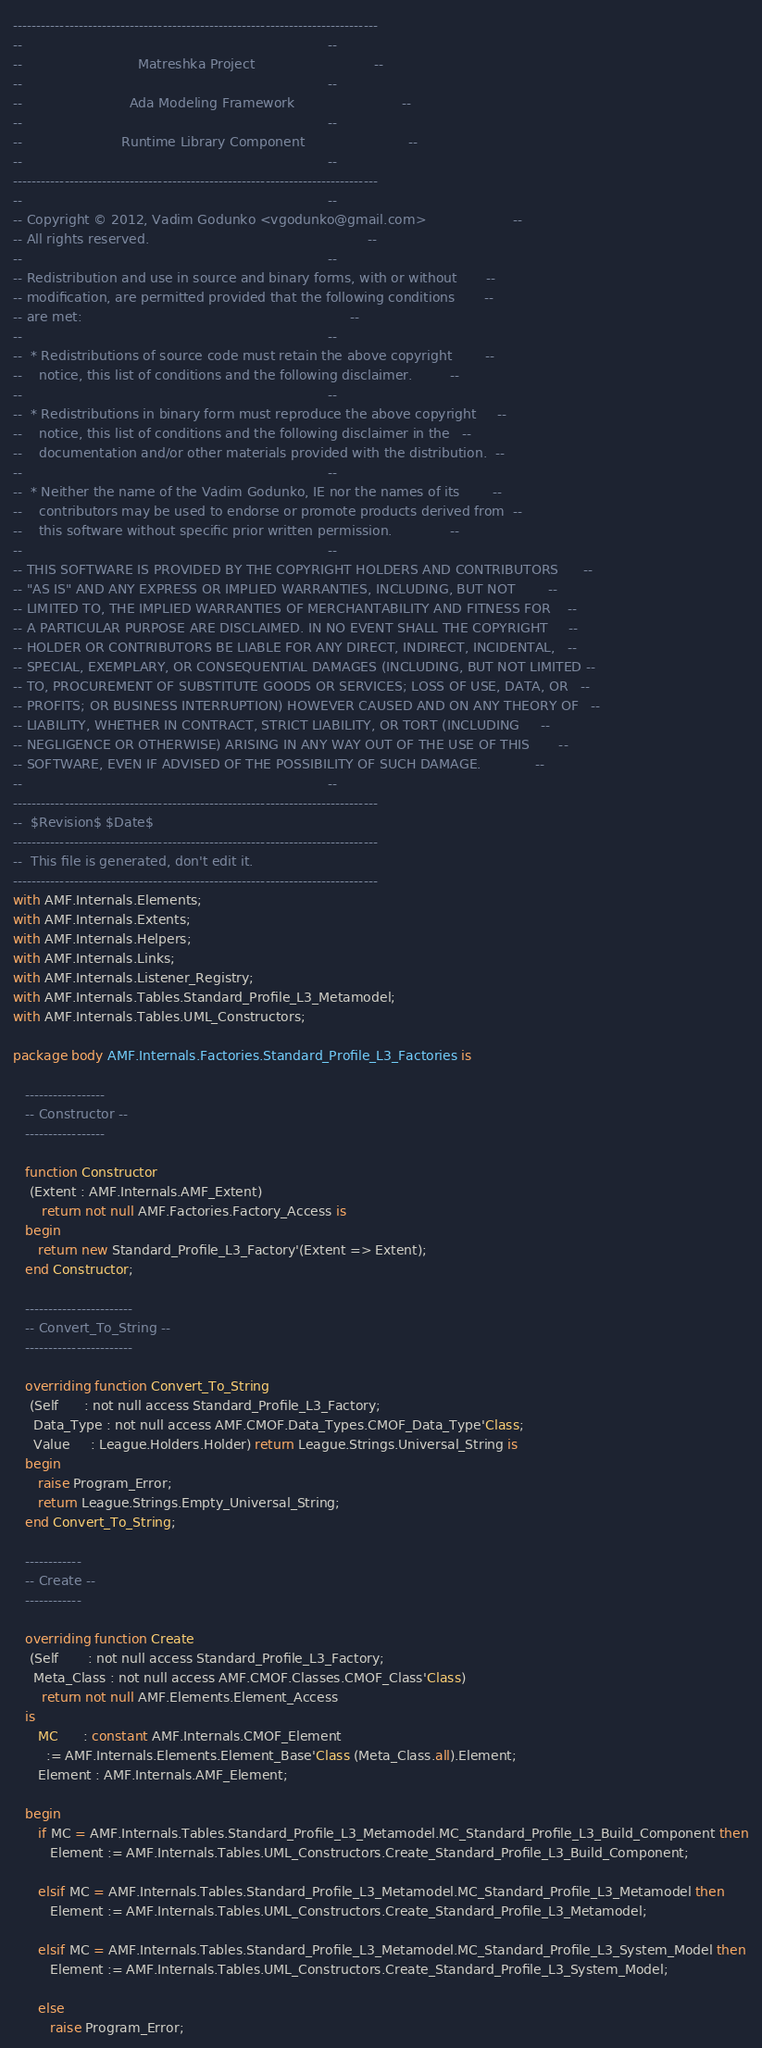<code> <loc_0><loc_0><loc_500><loc_500><_Ada_>------------------------------------------------------------------------------
--                                                                          --
--                            Matreshka Project                             --
--                                                                          --
--                          Ada Modeling Framework                          --
--                                                                          --
--                        Runtime Library Component                         --
--                                                                          --
------------------------------------------------------------------------------
--                                                                          --
-- Copyright © 2012, Vadim Godunko <vgodunko@gmail.com>                     --
-- All rights reserved.                                                     --
--                                                                          --
-- Redistribution and use in source and binary forms, with or without       --
-- modification, are permitted provided that the following conditions       --
-- are met:                                                                 --
--                                                                          --
--  * Redistributions of source code must retain the above copyright        --
--    notice, this list of conditions and the following disclaimer.         --
--                                                                          --
--  * Redistributions in binary form must reproduce the above copyright     --
--    notice, this list of conditions and the following disclaimer in the   --
--    documentation and/or other materials provided with the distribution.  --
--                                                                          --
--  * Neither the name of the Vadim Godunko, IE nor the names of its        --
--    contributors may be used to endorse or promote products derived from  --
--    this software without specific prior written permission.              --
--                                                                          --
-- THIS SOFTWARE IS PROVIDED BY THE COPYRIGHT HOLDERS AND CONTRIBUTORS      --
-- "AS IS" AND ANY EXPRESS OR IMPLIED WARRANTIES, INCLUDING, BUT NOT        --
-- LIMITED TO, THE IMPLIED WARRANTIES OF MERCHANTABILITY AND FITNESS FOR    --
-- A PARTICULAR PURPOSE ARE DISCLAIMED. IN NO EVENT SHALL THE COPYRIGHT     --
-- HOLDER OR CONTRIBUTORS BE LIABLE FOR ANY DIRECT, INDIRECT, INCIDENTAL,   --
-- SPECIAL, EXEMPLARY, OR CONSEQUENTIAL DAMAGES (INCLUDING, BUT NOT LIMITED --
-- TO, PROCUREMENT OF SUBSTITUTE GOODS OR SERVICES; LOSS OF USE, DATA, OR   --
-- PROFITS; OR BUSINESS INTERRUPTION) HOWEVER CAUSED AND ON ANY THEORY OF   --
-- LIABILITY, WHETHER IN CONTRACT, STRICT LIABILITY, OR TORT (INCLUDING     --
-- NEGLIGENCE OR OTHERWISE) ARISING IN ANY WAY OUT OF THE USE OF THIS       --
-- SOFTWARE, EVEN IF ADVISED OF THE POSSIBILITY OF SUCH DAMAGE.             --
--                                                                          --
------------------------------------------------------------------------------
--  $Revision$ $Date$
------------------------------------------------------------------------------
--  This file is generated, don't edit it.
------------------------------------------------------------------------------
with AMF.Internals.Elements;
with AMF.Internals.Extents;
with AMF.Internals.Helpers;
with AMF.Internals.Links;
with AMF.Internals.Listener_Registry;
with AMF.Internals.Tables.Standard_Profile_L3_Metamodel;
with AMF.Internals.Tables.UML_Constructors;

package body AMF.Internals.Factories.Standard_Profile_L3_Factories is

   -----------------
   -- Constructor --
   -----------------

   function Constructor
    (Extent : AMF.Internals.AMF_Extent)
       return not null AMF.Factories.Factory_Access is
   begin
      return new Standard_Profile_L3_Factory'(Extent => Extent);
   end Constructor;

   -----------------------
   -- Convert_To_String --
   -----------------------

   overriding function Convert_To_String
    (Self      : not null access Standard_Profile_L3_Factory;
     Data_Type : not null access AMF.CMOF.Data_Types.CMOF_Data_Type'Class;
     Value     : League.Holders.Holder) return League.Strings.Universal_String is
   begin
      raise Program_Error;
      return League.Strings.Empty_Universal_String;
   end Convert_To_String;

   ------------
   -- Create --
   ------------

   overriding function Create
    (Self       : not null access Standard_Profile_L3_Factory;
     Meta_Class : not null access AMF.CMOF.Classes.CMOF_Class'Class)
       return not null AMF.Elements.Element_Access
   is
      MC      : constant AMF.Internals.CMOF_Element
        := AMF.Internals.Elements.Element_Base'Class (Meta_Class.all).Element;
      Element : AMF.Internals.AMF_Element;

   begin
      if MC = AMF.Internals.Tables.Standard_Profile_L3_Metamodel.MC_Standard_Profile_L3_Build_Component then
         Element := AMF.Internals.Tables.UML_Constructors.Create_Standard_Profile_L3_Build_Component;

      elsif MC = AMF.Internals.Tables.Standard_Profile_L3_Metamodel.MC_Standard_Profile_L3_Metamodel then
         Element := AMF.Internals.Tables.UML_Constructors.Create_Standard_Profile_L3_Metamodel;

      elsif MC = AMF.Internals.Tables.Standard_Profile_L3_Metamodel.MC_Standard_Profile_L3_System_Model then
         Element := AMF.Internals.Tables.UML_Constructors.Create_Standard_Profile_L3_System_Model;

      else
         raise Program_Error;</code> 